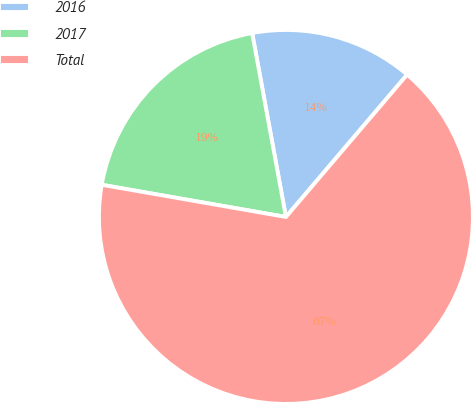<chart> <loc_0><loc_0><loc_500><loc_500><pie_chart><fcel>2016<fcel>2017<fcel>Total<nl><fcel>14.12%<fcel>19.36%<fcel>66.53%<nl></chart> 